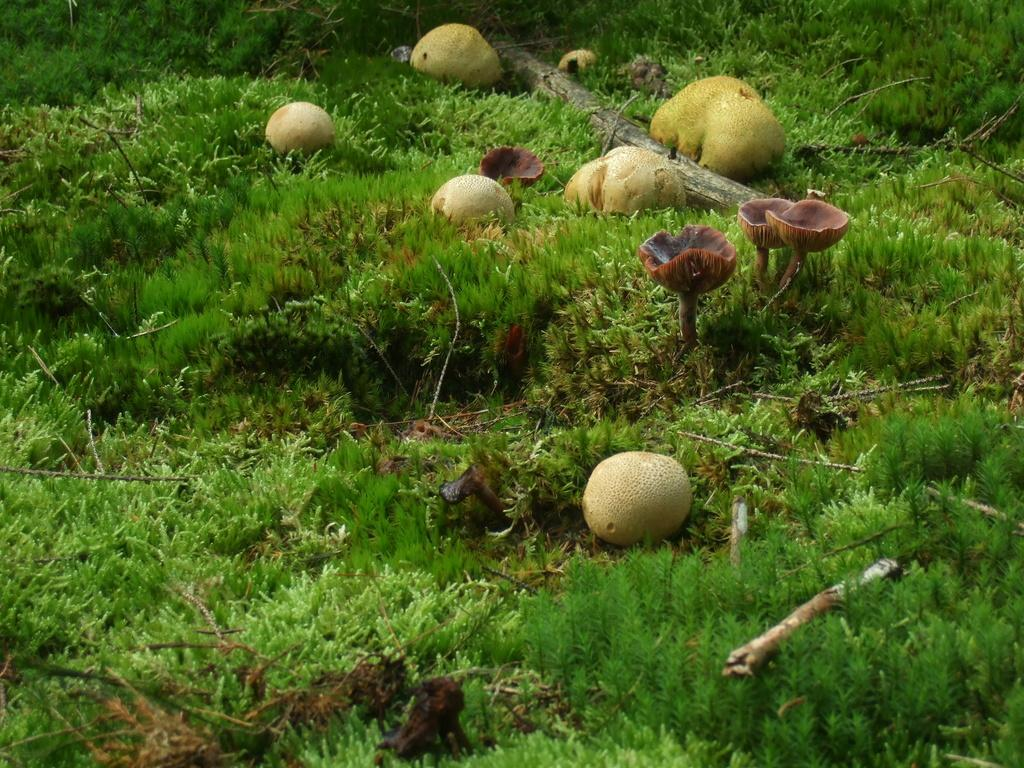What type of vegetation is present on the ground in the image? There is grass and plants on the ground in the image. What specific type of plant can be seen in the middle of the image? There are mushrooms in the middle of the image. What type of advertisement can be seen on the mushrooms in the image? There is no advertisement present on the mushrooms in the image. How does the harmony of the plants and mushrooms contribute to the overall aesthetic of the image? The provided facts do not mention harmony or aesthetics, so we cannot comment on how the plants and mushrooms contribute to the overall aesthetic of the image. 